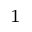Convert formula to latex. <formula><loc_0><loc_0><loc_500><loc_500>_ { 1 }</formula> 